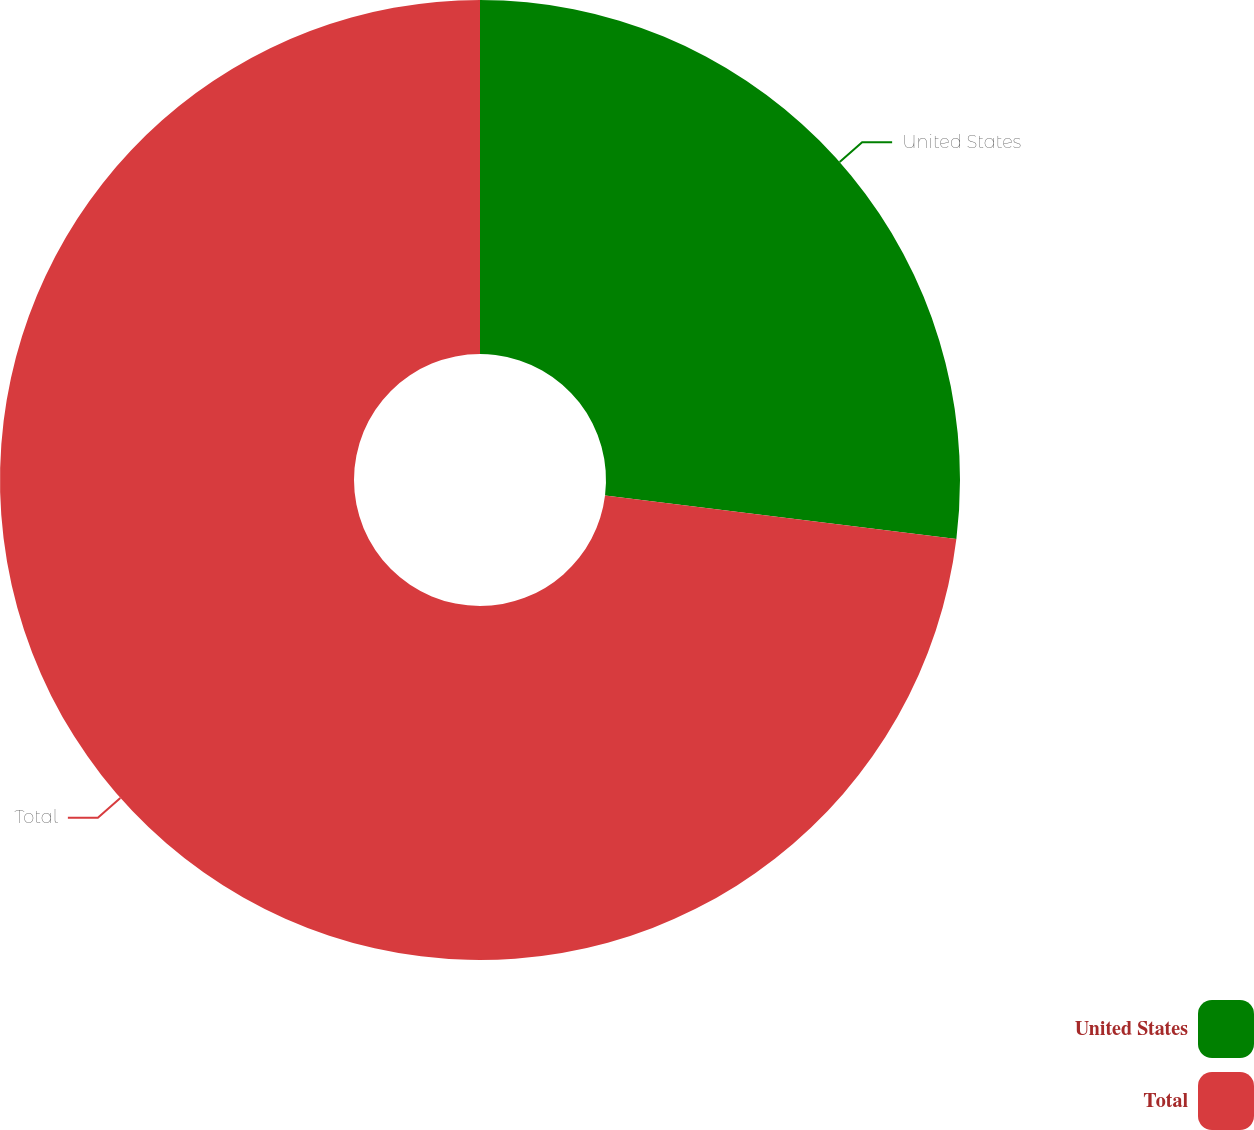Convert chart to OTSL. <chart><loc_0><loc_0><loc_500><loc_500><pie_chart><fcel>United States<fcel>Total<nl><fcel>26.96%<fcel>73.04%<nl></chart> 